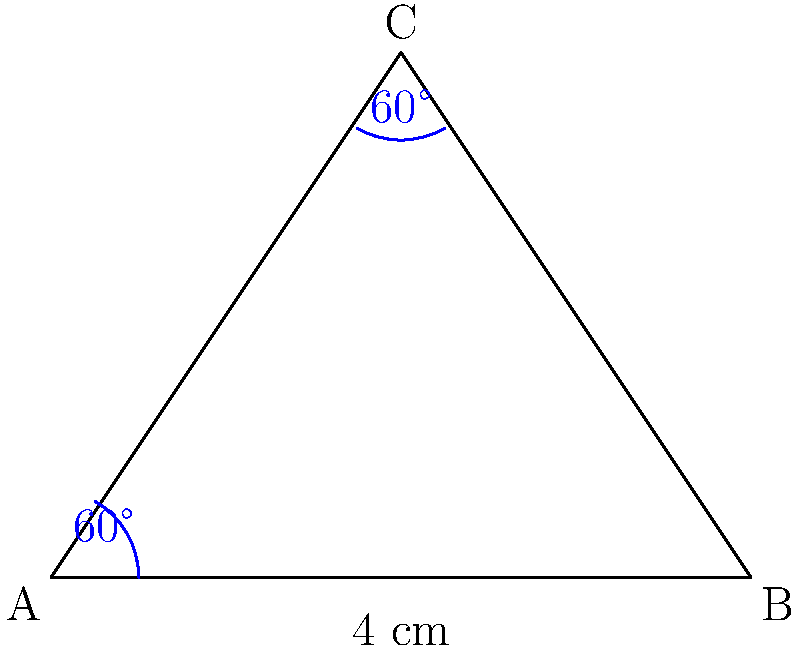A picture frame has the shape of an isosceles triangle. Two of its angles measure 60°, and the base is 4 cm long. Using the Angle-Side-Angle (ASA) congruence criterion, determine if two such picture frames would be congruent. If so, what is the length of one of the equal sides? Let's approach this step-by-step:

1) First, we need to identify what we know:
   - Two angles of the triangle are 60°
   - The base (side between these angles) is 4 cm

2) For ASA congruence, we need two angles and the included side to be equal in both triangles. We have this information for both frames.

3) Since the triangle is isosceles and two angles are 60°, we can deduce:
   - The third angle must be 180° - (60° + 60°) = 60°
   - This means it's an equilateral triangle

4) For two triangles to be congruent by ASA:
   - Two pairs of angles must be equal (we have 60° for both)
   - The included side must be equal (we have 4 cm for both)

5) Therefore, the two picture frames would indeed be congruent.

6) To find the length of one of the equal sides:
   - In an equilateral triangle, all sides are equal
   - So, each side of the triangle is 4 cm long

Therefore, the length of one of the equal sides is 4 cm.
Answer: Yes, congruent; 4 cm 